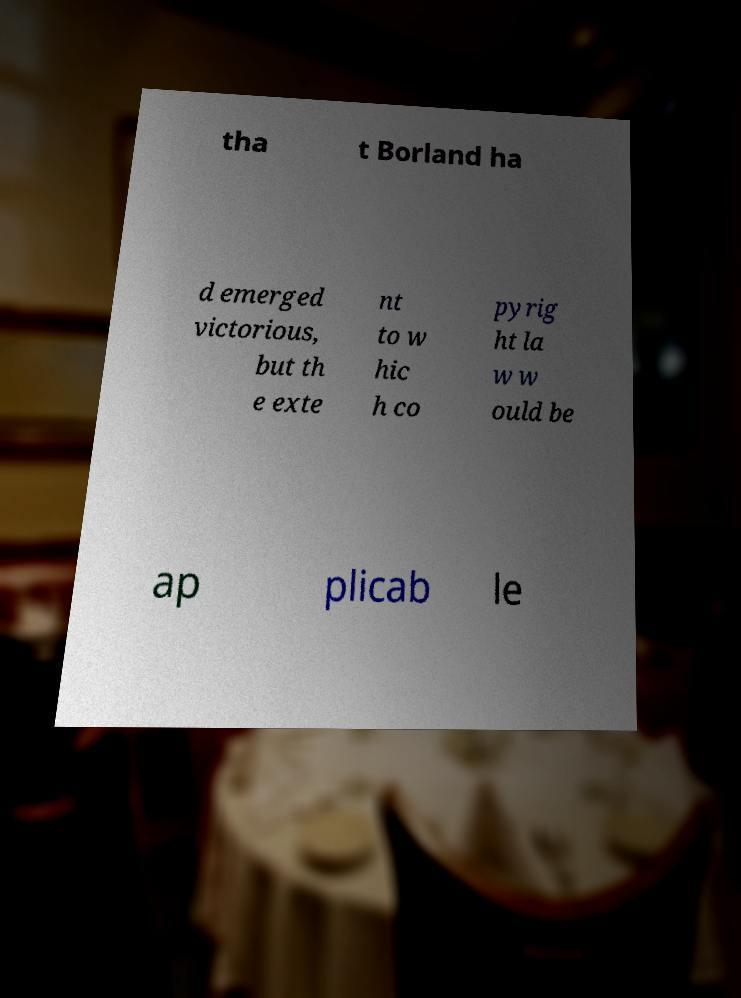Please read and relay the text visible in this image. What does it say? tha t Borland ha d emerged victorious, but th e exte nt to w hic h co pyrig ht la w w ould be ap plicab le 